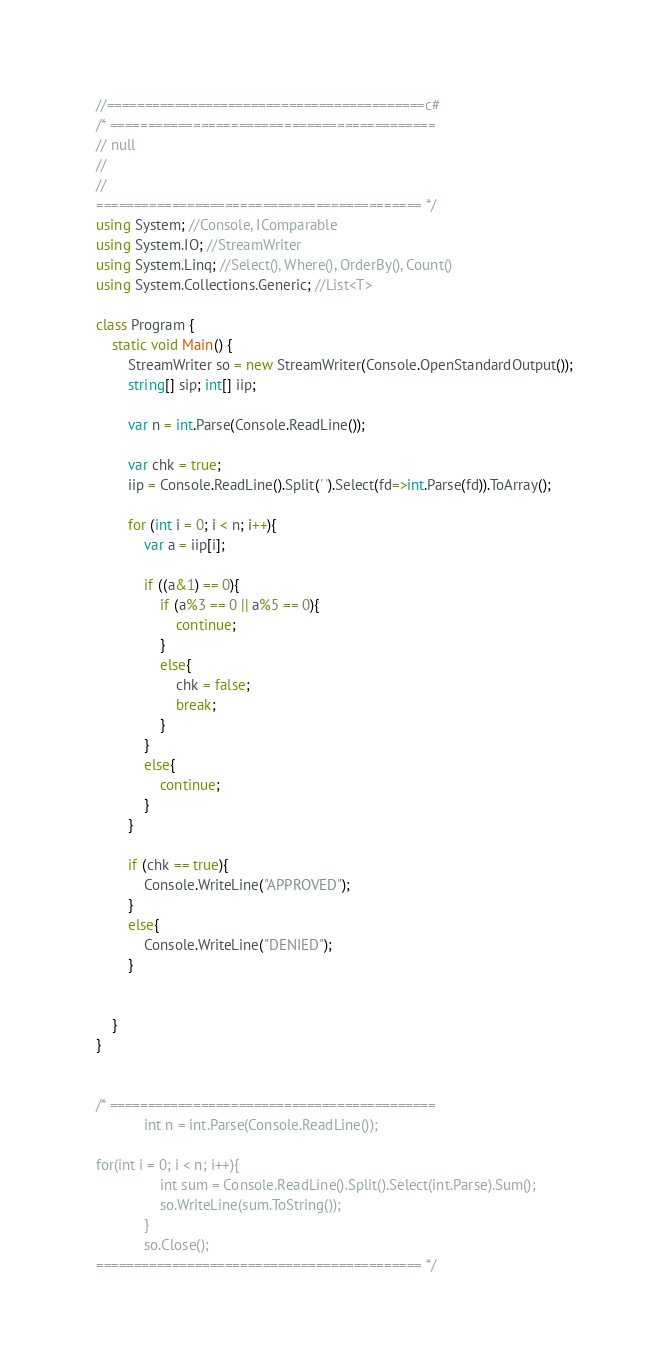<code> <loc_0><loc_0><loc_500><loc_500><_C#_>//==========================================c#
/* ===========================================
// null
// 
// 
=========================================== */
using System; //Console, IComparable
using System.IO; //StreamWriter 
using System.Linq; //Select(), Where(), OrderBy(), Count()
using System.Collections.Generic; //List<T>

class Program { 
    static void Main() { 
        StreamWriter so = new StreamWriter(Console.OpenStandardOutput());
        string[] sip; int[] iip;
        
        var n = int.Parse(Console.ReadLine());
        
        var chk = true;
        iip = Console.ReadLine().Split(' ').Select(fd=>int.Parse(fd)).ToArray();
        
        for (int i = 0; i < n; i++){
            var a = iip[i];
            
            if ((a&1) == 0){
                if (a%3 == 0 || a%5 == 0){
                    continue;
                }
                else{
                    chk = false;
                    break;
                }
            }
            else{
                continue;
            }
        }

        if (chk == true){
            Console.WriteLine("APPROVED");
        }
        else{
            Console.WriteLine("DENIED"); 
        }


    } 
}


/* ===========================================
            int n = int.Parse(Console.ReadLine());

for(int i = 0; i < n; i++){
                int sum = Console.ReadLine().Split().Select(int.Parse).Sum();
                so.WriteLine(sum.ToString());
            }
            so.Close();
=========================================== */</code> 